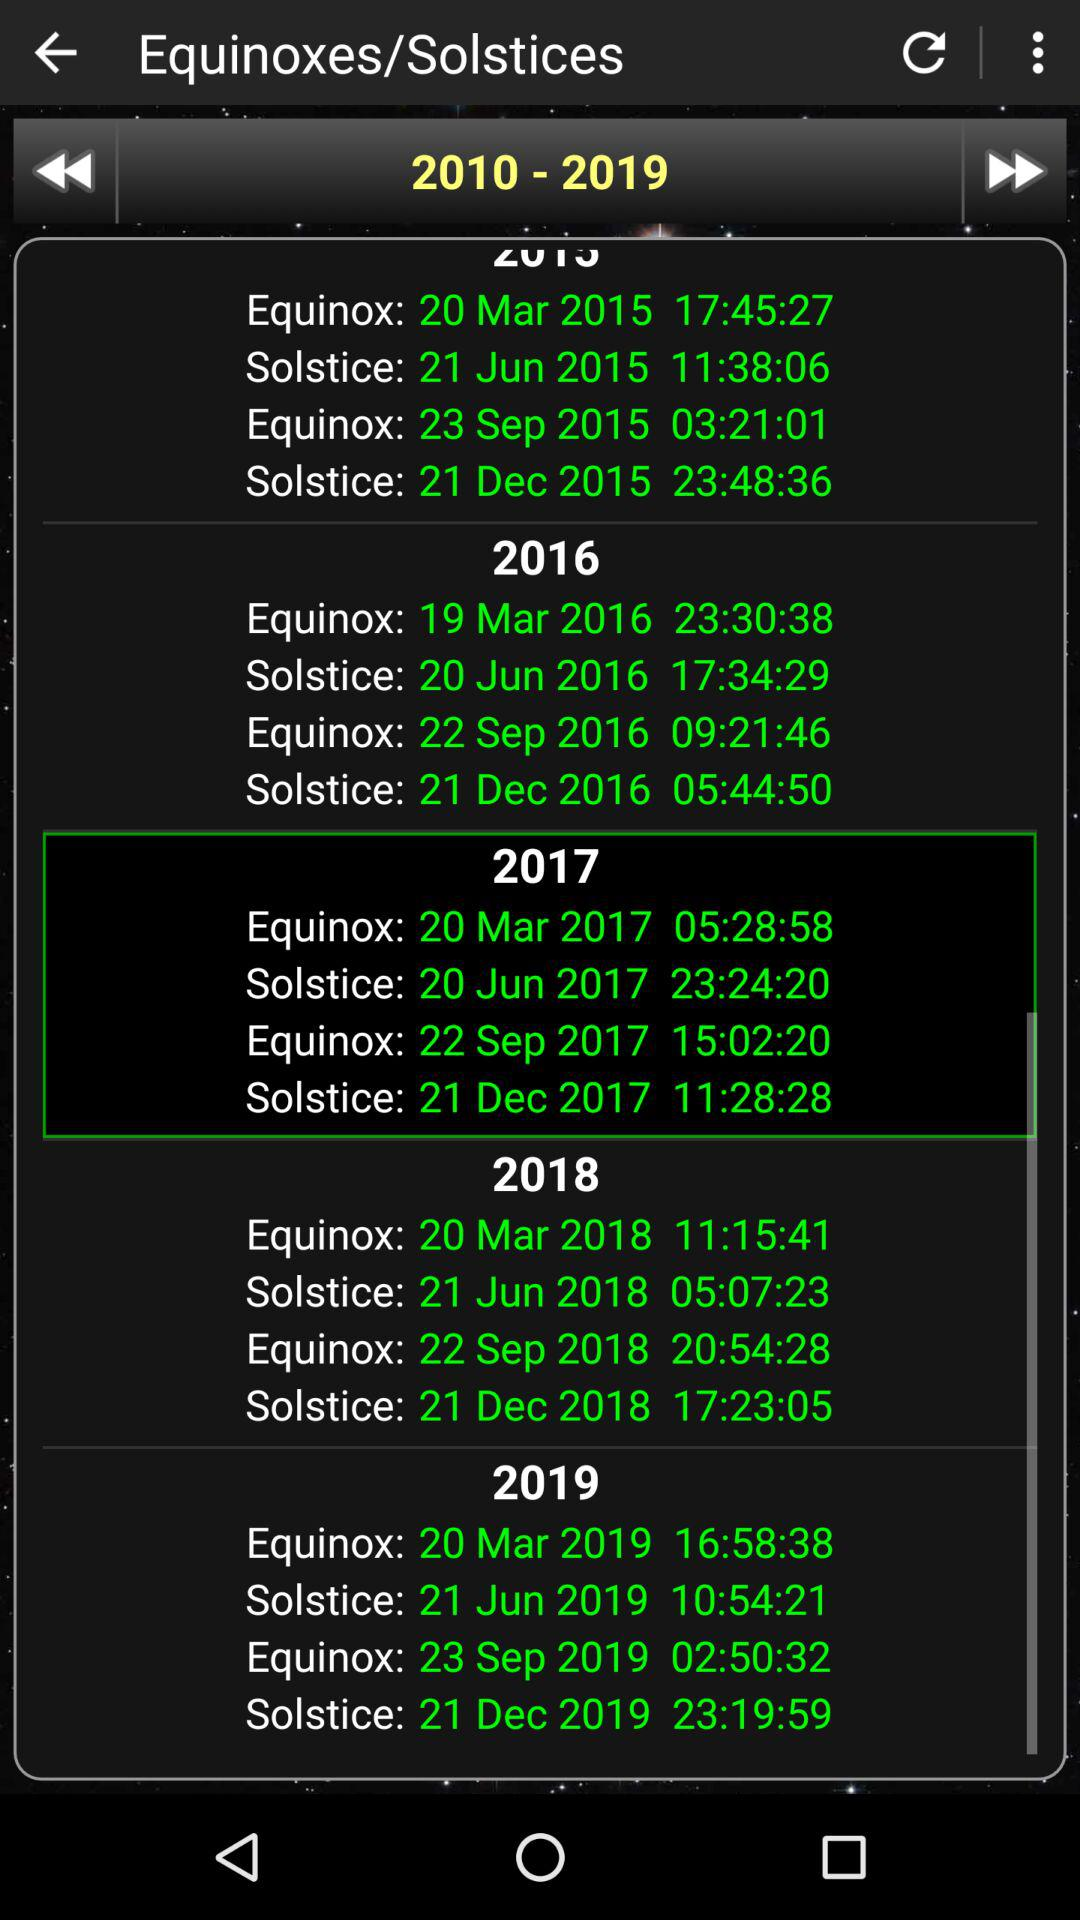What is the date and time of the first equinox of 2016? The date and time of the first equinox of 2016 are March 19, 2016 at 23:30:38. 